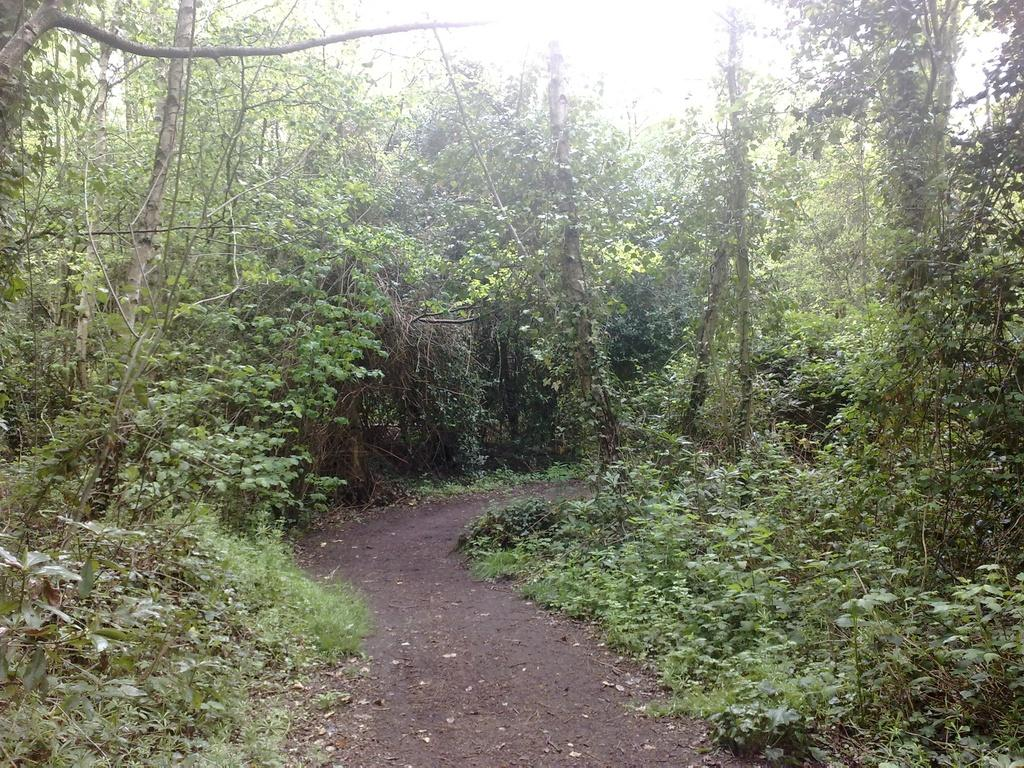What type of vegetation can be seen in the image? There are many trees and plants in the image. Can you describe the lighting in the image? There is bright sunshine at the top center of the image. What type of ocean can be seen in the image? There is no ocean present in the image; it features trees and plants with bright sunshine. Can you describe the shape of the church in the image? There is no church present in the image; it only contains trees, plants, and bright sunshine. 